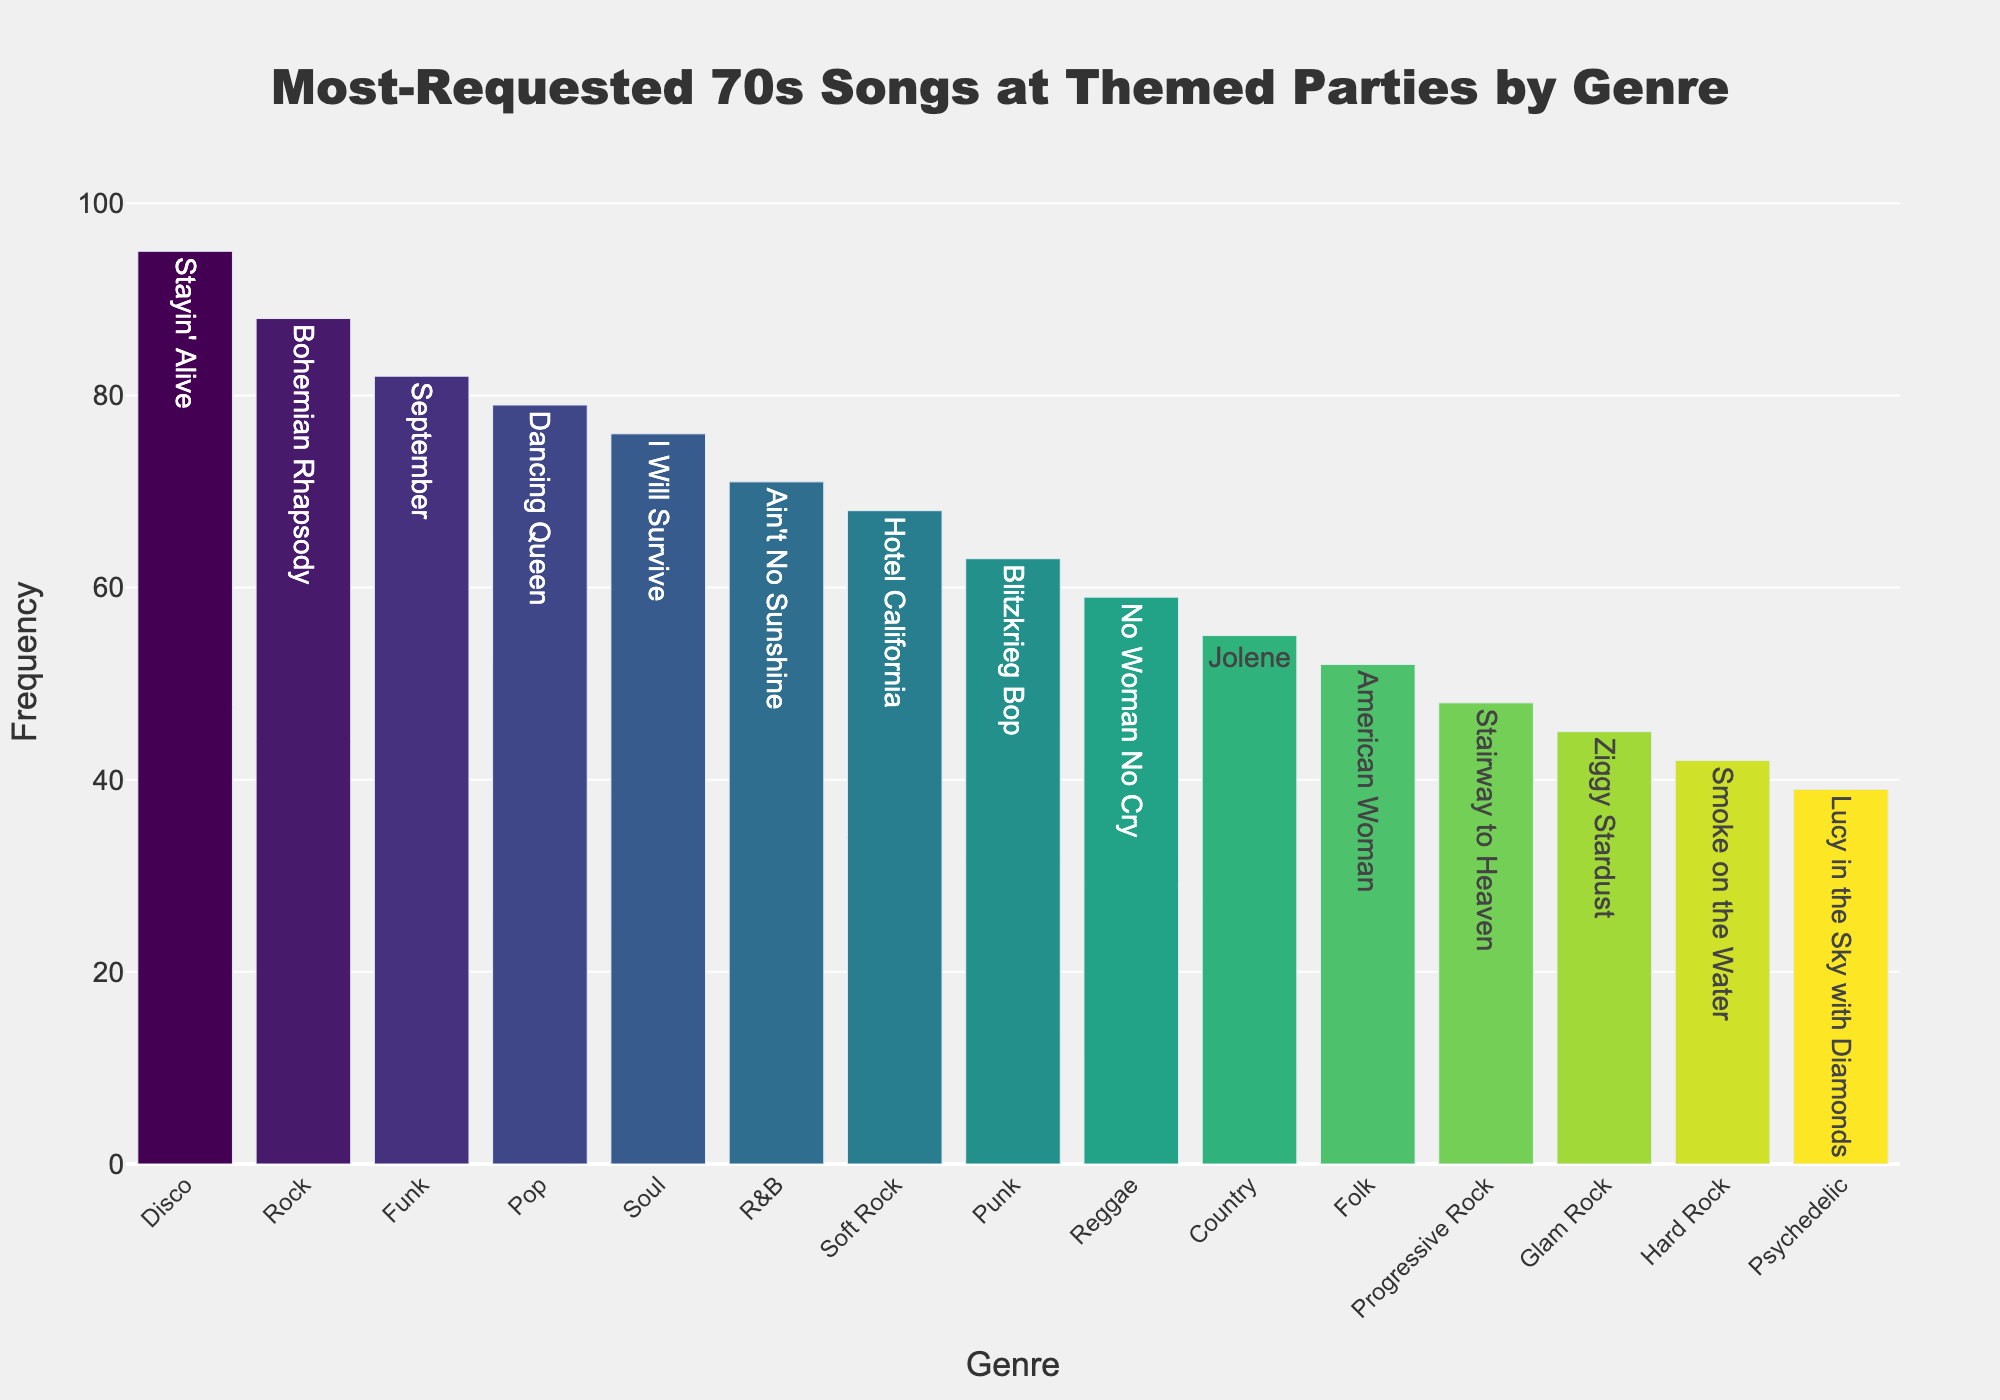Which genre has the most-requested song? The bar chart shows that the highest frequency bar is for Disco, with "Stayin' Alive" being the most-requested song.
Answer: Disco What are the second and third most-requested songs, and what genres do they belong to? The bar chart shows that the second highest frequency bar is for Rock with "Bohemian Rhapsody" and the third highest is for Funk with "September".
Answer: "Bohemian Rhapsody" (Rock) and "September" (Funk) How does the frequency of "Stayin' Alive" compare to "Bohemian Rhapsody"? The frequency of "Stayin' Alive" (95) is higher than "Bohemian Rhapsody" (88). Subtracting the two frequencies gives 95 - 88 = 7.
Answer: Stayin' Alive is 7 more than Bohemian Rhapsody What is the combined frequency of the most-requested songs in the Pop, Soul, and R&B genres? The frequencies are 79 (Pop), 76 (Soul), and 71 (R&B). Adding these values together gives 79 + 76 + 71 = 226.
Answer: 226 Which genre has the least-requested song, and what is its frequency? The genre with the least-requested song is Psychedelic, with "Lucy in the Sky with Diamonds" having a frequency of 39.
Answer: Psychedelic, 39 What is the average frequency of the top five most-requested songs? The top five frequencies are 95, 88, 82, 79, and 76. Adding these, we get 95 + 88 + 82 + 79 + 76 = 420. Dividing by 5 gives 420 / 5 = 84.
Answer: 84 Which genre has a higher request frequency, Country or Folk, and by how much? The frequency for Country is 55, and for Folk, it is 52. Subtracting these, we get 55 - 52 = 3.
Answer: Country, by 3 Compare the visual lengths of the bars for Hard Rock and Progressive Rock, and determine which one has the higher frequency. The bar for Hard Rock has a height of 42, while the bar for Progressive Rock has a height of 48. The Progressive Rock bar is taller.
Answer: Progressive Rock Which genres have songs with a frequency between 50 and 70? The genres falling within this range are Soft Rock (68), Punk (63), Reggae (59), Country (55), and Folk (52).
Answer: Soft Rock, Punk, Reggae, Country, Folk How many genres have a most-requested song with a frequency above 80? The frequencies above 80 are Disco (95), Rock (88), and Funk (82). There are 3 genres in this category.
Answer: 3 genres 